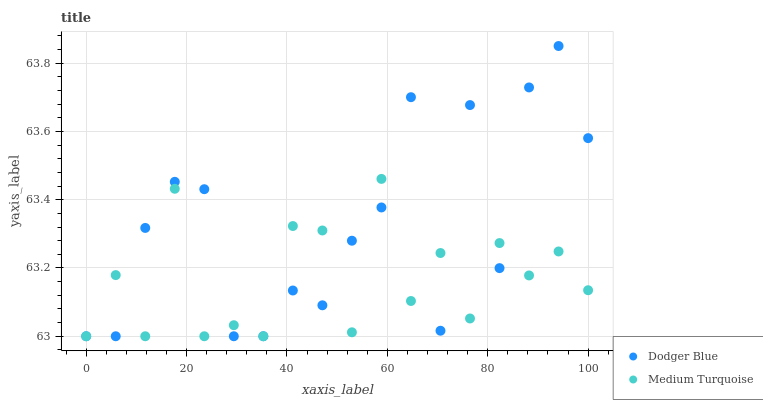Does Medium Turquoise have the minimum area under the curve?
Answer yes or no. Yes. Does Dodger Blue have the maximum area under the curve?
Answer yes or no. Yes. Does Medium Turquoise have the maximum area under the curve?
Answer yes or no. No. Is Medium Turquoise the smoothest?
Answer yes or no. Yes. Is Dodger Blue the roughest?
Answer yes or no. Yes. Is Medium Turquoise the roughest?
Answer yes or no. No. Does Dodger Blue have the lowest value?
Answer yes or no. Yes. Does Dodger Blue have the highest value?
Answer yes or no. Yes. Does Medium Turquoise have the highest value?
Answer yes or no. No. Does Dodger Blue intersect Medium Turquoise?
Answer yes or no. Yes. Is Dodger Blue less than Medium Turquoise?
Answer yes or no. No. Is Dodger Blue greater than Medium Turquoise?
Answer yes or no. No. 